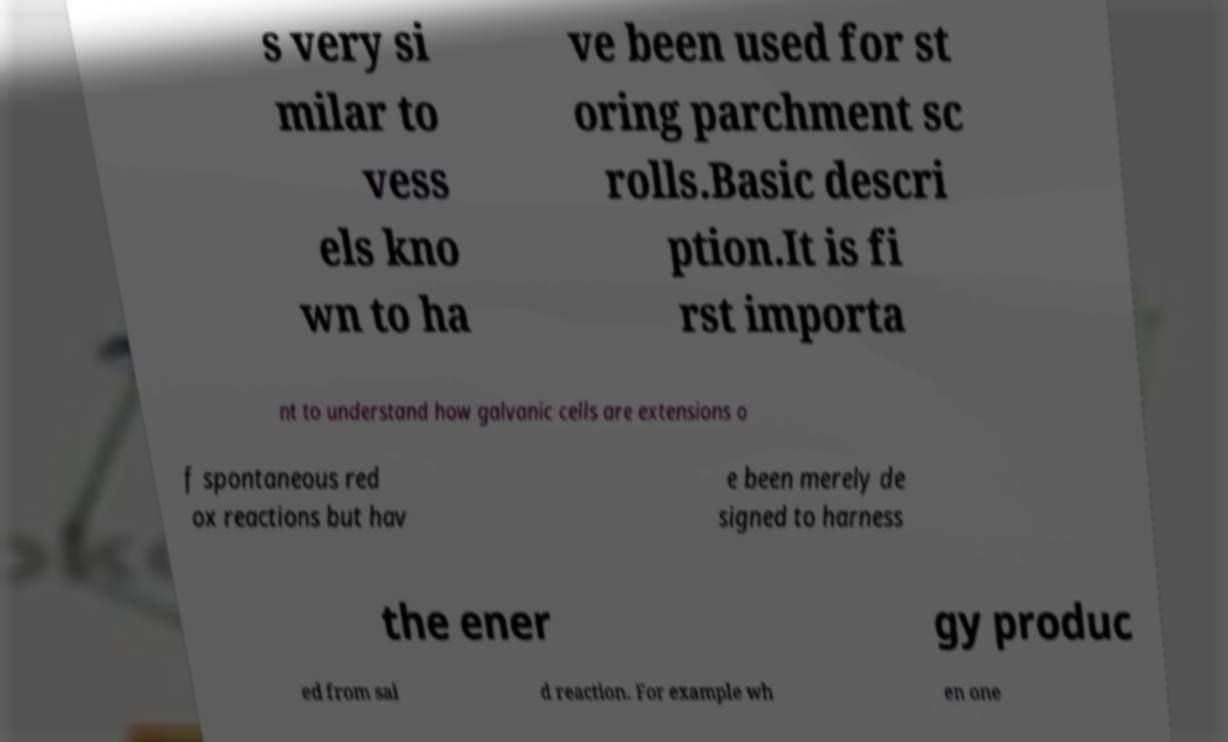There's text embedded in this image that I need extracted. Can you transcribe it verbatim? s very si milar to vess els kno wn to ha ve been used for st oring parchment sc rolls.Basic descri ption.It is fi rst importa nt to understand how galvanic cells are extensions o f spontaneous red ox reactions but hav e been merely de signed to harness the ener gy produc ed from sai d reaction. For example wh en one 